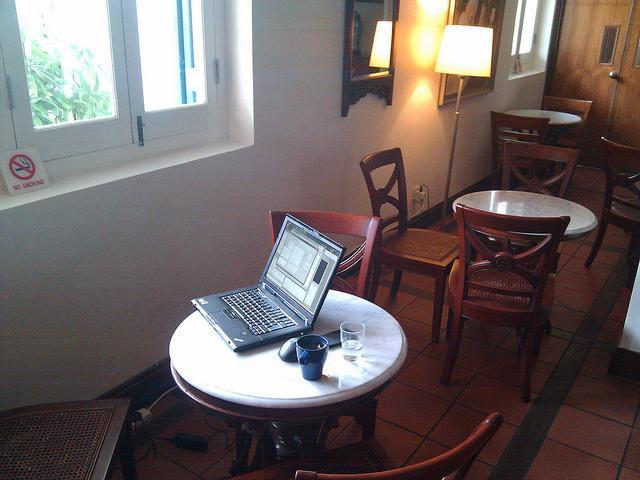How many dining tables are in the photo?
Give a very brief answer. 2. How many chairs are in the photo?
Give a very brief answer. 8. How many cars are on the right of the horses and riders?
Give a very brief answer. 0. 